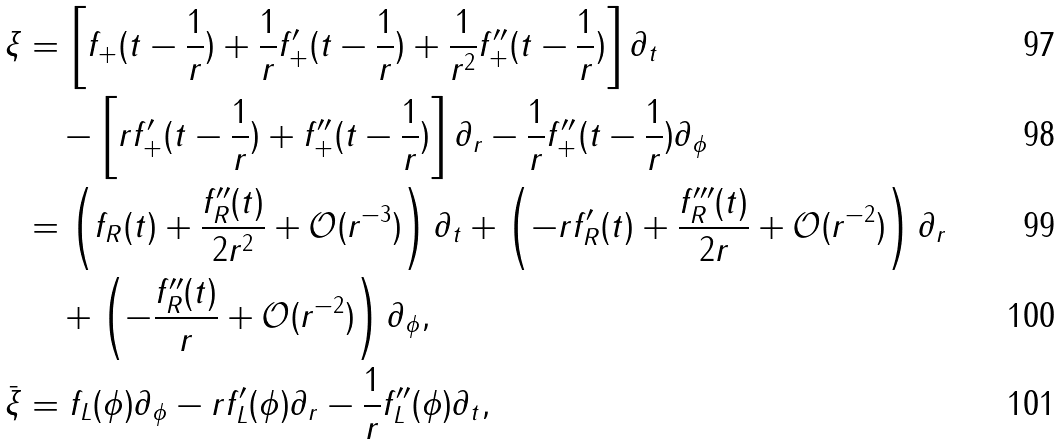<formula> <loc_0><loc_0><loc_500><loc_500>\xi & = \left [ f _ { + } ( t - \frac { 1 } { r } ) + \frac { 1 } { r } f _ { + } ^ { \prime } ( t - \frac { 1 } { r } ) + \frac { 1 } { r ^ { 2 } } f _ { + } ^ { \prime \prime } ( t - \frac { 1 } { r } ) \right ] \partial _ { t } \\ & \quad - \left [ r f _ { + } ^ { \prime } ( t - \frac { 1 } { r } ) + f _ { + } ^ { \prime \prime } ( t - \frac { 1 } { r } ) \right ] \partial _ { r } - \frac { 1 } { r } f _ { + } ^ { \prime \prime } ( t - \frac { 1 } { r } ) \partial _ { \phi } \\ & = \left ( f _ { R } ( t ) + \frac { f _ { R } ^ { \prime \prime } ( t ) } { 2 r ^ { 2 } } + \mathcal { O } ( r ^ { - 3 } ) \right ) \partial _ { t } + \left ( - r f _ { R } ^ { \prime } ( t ) + \frac { f _ { R } ^ { \prime \prime \prime } ( t ) } { 2 r } + \mathcal { O } ( r ^ { - 2 } ) \right ) \partial _ { r } \\ & \quad + \left ( - \frac { f _ { R } ^ { \prime \prime } ( t ) } { r } + \mathcal { O } ( r ^ { - 2 } ) \right ) \partial _ { \phi } , \\ \bar { \xi } & = f _ { L } ( \phi ) \partial _ { \phi } - r f _ { L } ^ { \prime } ( \phi ) \partial _ { r } - \frac { 1 } { r } f _ { L } ^ { \prime \prime } ( \phi ) \partial _ { t } ,</formula> 